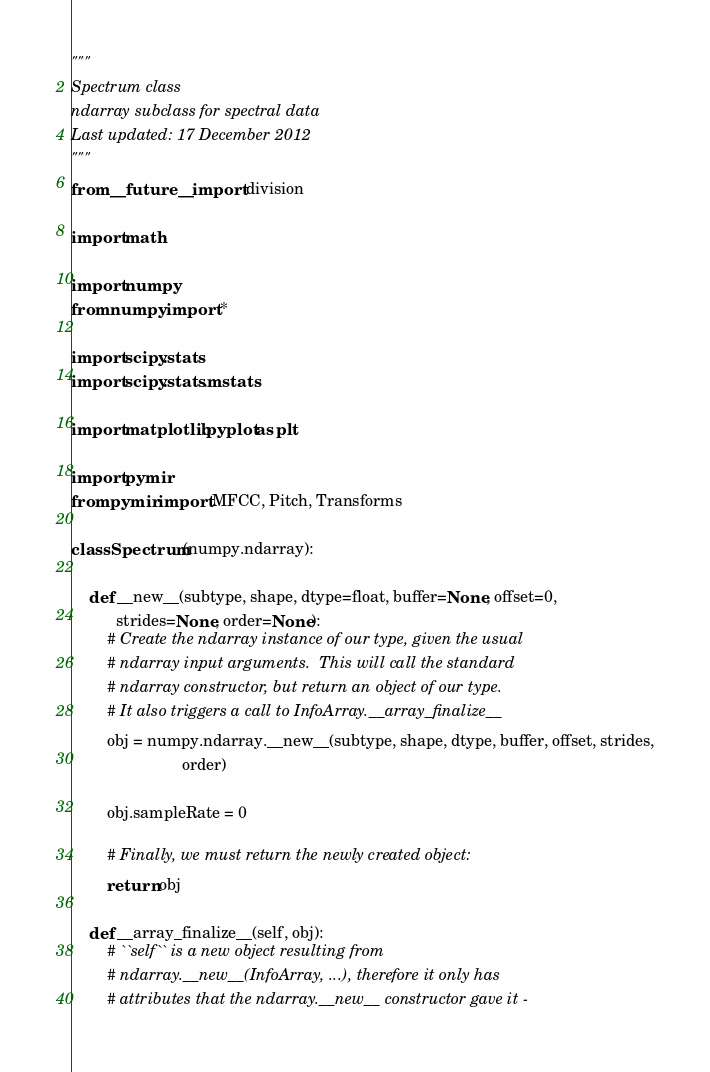<code> <loc_0><loc_0><loc_500><loc_500><_Python_>"""
Spectrum class
ndarray subclass for spectral data
Last updated: 17 December 2012
"""
from __future__ import division

import math

import numpy
from numpy import *

import scipy.stats
import scipy.stats.mstats

import matplotlib.pyplot as plt

import pymir
from pymir import MFCC, Pitch, Transforms

class Spectrum(numpy.ndarray):
    
    def __new__(subtype, shape, dtype=float, buffer=None, offset=0,
          strides=None, order=None):
        # Create the ndarray instance of our type, given the usual
        # ndarray input arguments.  This will call the standard
        # ndarray constructor, but return an object of our type.
        # It also triggers a call to InfoArray.__array_finalize__
        obj = numpy.ndarray.__new__(subtype, shape, dtype, buffer, offset, strides,
                         order)
        
        obj.sampleRate = 0
        
        # Finally, we must return the newly created object:
        return obj
    
    def __array_finalize__(self, obj):
        # ``self`` is a new object resulting from
        # ndarray.__new__(InfoArray, ...), therefore it only has
        # attributes that the ndarray.__new__ constructor gave it -</code> 